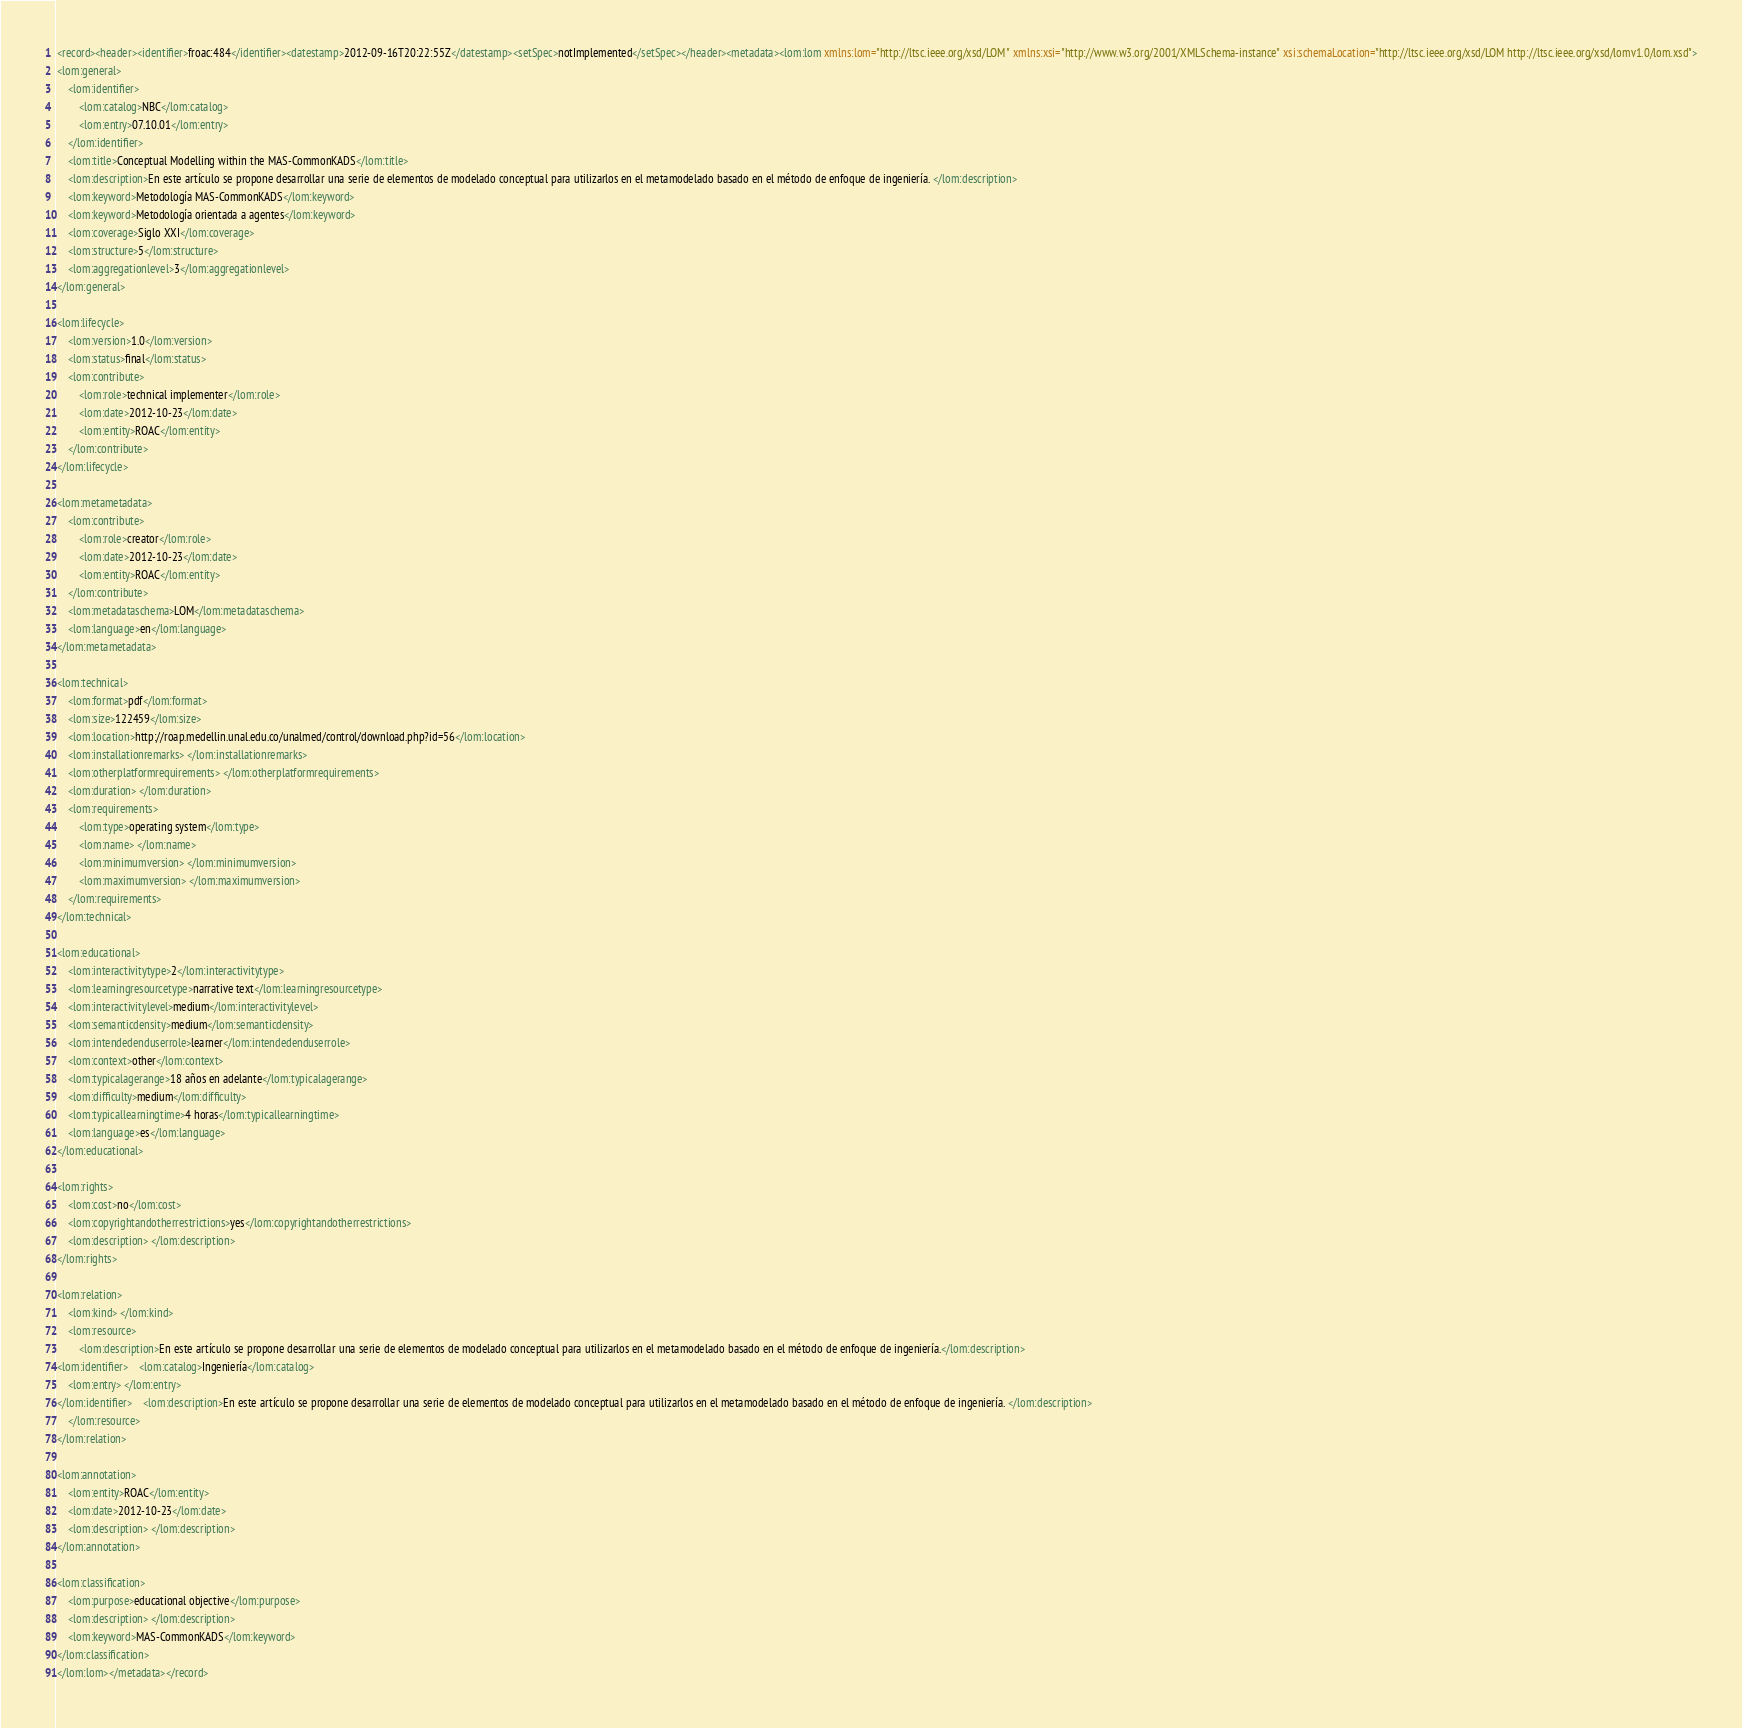<code> <loc_0><loc_0><loc_500><loc_500><_XML_><record><header><identifier>froac:484</identifier><datestamp>2012-09-16T20:22:55Z</datestamp><setSpec>notImplemented</setSpec></header><metadata><lom:lom xmlns:lom="http://ltsc.ieee.org/xsd/LOM" xmlns:xsi="http://www.w3.org/2001/XMLSchema-instance" xsi:schemaLocation="http://ltsc.ieee.org/xsd/LOM http://ltsc.ieee.org/xsd/lomv1.0/lom.xsd">
<lom:general>
	<lom:identifier>
		<lom:catalog>NBC</lom:catalog>
		<lom:entry>07.10.01</lom:entry>
	</lom:identifier>
	<lom:title>Conceptual Modelling within the MAS-CommonKADS</lom:title>
	<lom:description>En este artículo se propone desarrollar una serie de elementos de modelado conceptual para utilizarlos en el metamodelado basado en el método de enfoque de ingeniería. </lom:description>
	<lom:keyword>Metodología MAS-CommonKADS</lom:keyword>
	<lom:keyword>Metodología orientada a agentes</lom:keyword>
	<lom:coverage>Siglo XXI</lom:coverage>
	<lom:structure>5</lom:structure>
	<lom:aggregationlevel>3</lom:aggregationlevel>
</lom:general>

<lom:lifecycle>
	<lom:version>1.0</lom:version>
	<lom:status>final</lom:status>
	<lom:contribute>
		<lom:role>technical implementer</lom:role>
		<lom:date>2012-10-23</lom:date>
		<lom:entity>ROAC</lom:entity>
	</lom:contribute>
</lom:lifecycle>

<lom:metametadata>
	<lom:contribute>
		<lom:role>creator</lom:role>
		<lom:date>2012-10-23</lom:date>
		<lom:entity>ROAC</lom:entity>
	</lom:contribute>
	<lom:metadataschema>LOM</lom:metadataschema>
	<lom:language>en</lom:language>
</lom:metametadata>

<lom:technical>
	<lom:format>pdf</lom:format>
	<lom:size>122459</lom:size>
	<lom:location>http://roap.medellin.unal.edu.co/unalmed/control/download.php?id=56</lom:location>
	<lom:installationremarks> </lom:installationremarks>
	<lom:otherplatformrequirements> </lom:otherplatformrequirements>
	<lom:duration> </lom:duration>
	<lom:requirements>
		<lom:type>operating system</lom:type>
		<lom:name> </lom:name>
		<lom:minimumversion> </lom:minimumversion>
		<lom:maximumversion> </lom:maximumversion>
	</lom:requirements>
</lom:technical>

<lom:educational>
	<lom:interactivitytype>2</lom:interactivitytype>
	<lom:learningresourcetype>narrative text</lom:learningresourcetype>
	<lom:interactivitylevel>medium</lom:interactivitylevel>
	<lom:semanticdensity>medium</lom:semanticdensity>
	<lom:intendedenduserrole>learner</lom:intendedenduserrole>
	<lom:context>other</lom:context>
	<lom:typicalagerange>18 años en adelante</lom:typicalagerange>
	<lom:difficulty>medium</lom:difficulty>
	<lom:typicallearningtime>4 horas</lom:typicallearningtime>
	<lom:language>es</lom:language>
</lom:educational>

<lom:rights>
	<lom:cost>no</lom:cost>
	<lom:copyrightandotherrestrictions>yes</lom:copyrightandotherrestrictions>
	<lom:description> </lom:description>
</lom:rights>

<lom:relation>
	<lom:kind> </lom:kind>
	<lom:resource>
		<lom:description>En este artículo se propone desarrollar una serie de elementos de modelado conceptual para utilizarlos en el metamodelado basado en el método de enfoque de ingeniería.</lom:description>
<lom:identifier>	<lom:catalog>Ingeniería</lom:catalog>
	<lom:entry> </lom:entry>
</lom:identifier>	<lom:description>En este artículo se propone desarrollar una serie de elementos de modelado conceptual para utilizarlos en el metamodelado basado en el método de enfoque de ingeniería. </lom:description>
	</lom:resource>
</lom:relation>

<lom:annotation>
	<lom:entity>ROAC</lom:entity>
	<lom:date>2012-10-23</lom:date>
	<lom:description> </lom:description>
</lom:annotation>

<lom:classification>
	<lom:purpose>educational objective</lom:purpose>
	<lom:description> </lom:description>
	<lom:keyword>MAS-CommonKADS</lom:keyword>
</lom:classification>
</lom:lom></metadata></record></code> 